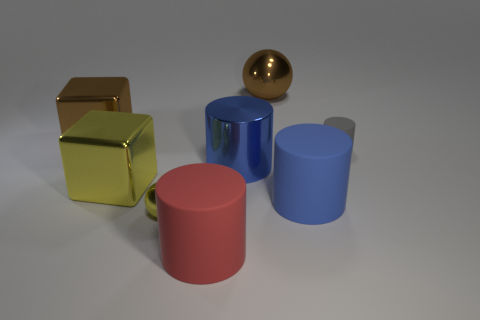What colors are the other geometric objects in this image? In the image, there are a variety of colors represented among the geometric objects. Specifically, there is a golden cube, a blue cylinder, a pink cylinder, and a translucent blue half-cylinder. 